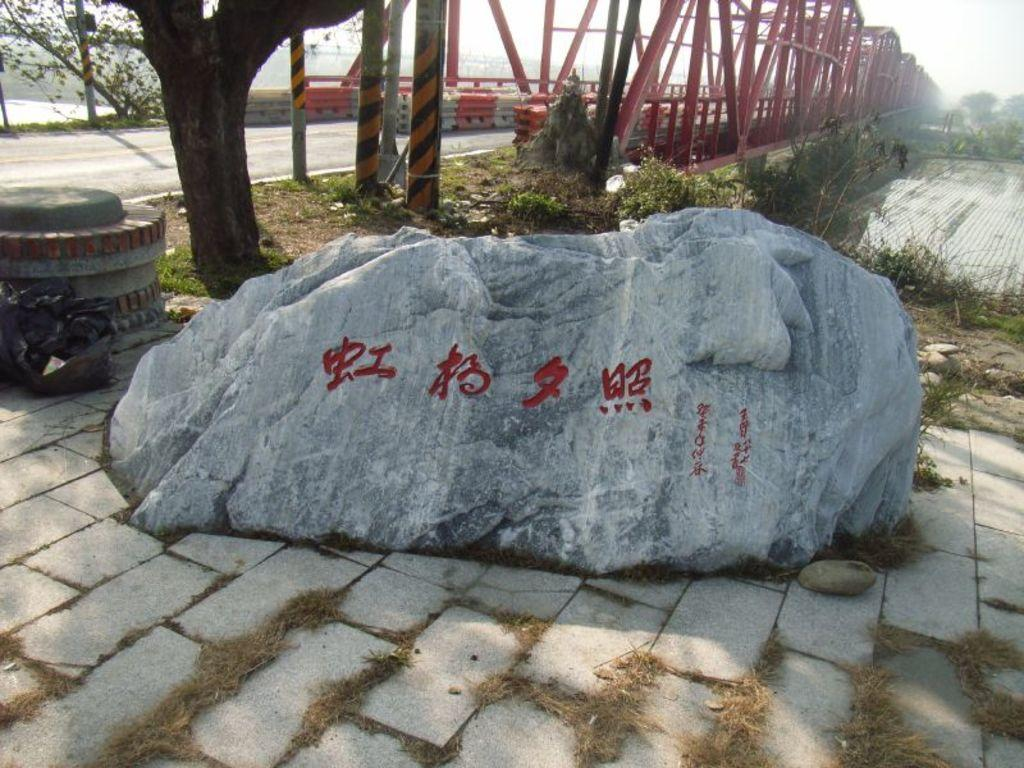What type of natural formation can be seen in the image? There is a rock in the image. What type of vegetation is present in the image? There is grass and plants in the image. What type of structure can be seen in the image? There is a bridge in the image. What is the color of the bridge's iron frame? The bridge has a red color iron frame. What else can be seen in the image? There is a tree and a road in the image. Can you see a monkey climbing the tree in the image? There is no monkey present in the image; it only features a tree, a rock, grass, plants, a road, and a bridge with a red iron frame. What type of cheese is being used to build the bridge in the image? There is no cheese present in the image; the bridge has a red color iron frame. 